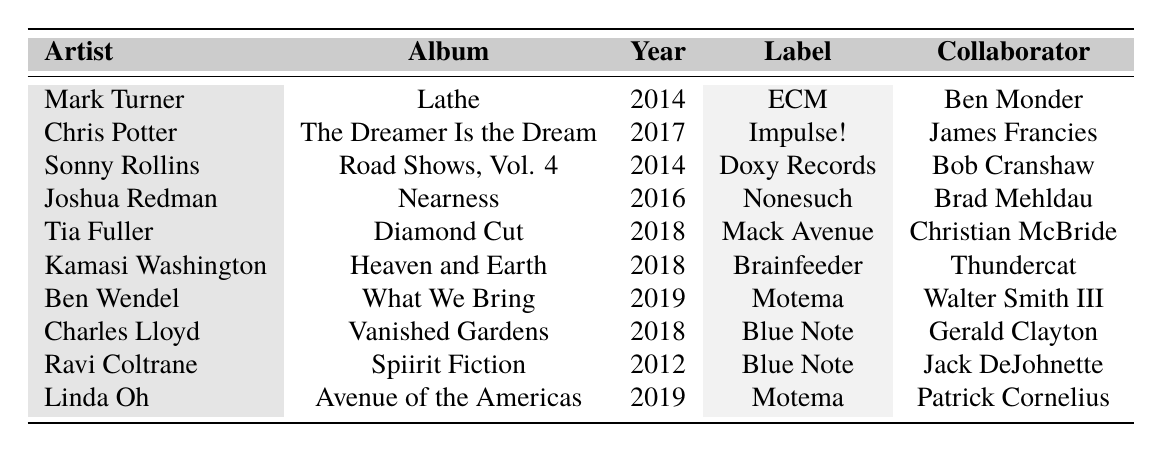What is the title of Mark Turner's album? According to the table, Mark Turner's album is titled "Lathe."
Answer: Lathe How many albums were released by saxophonists in 2018? The table shows three saxophonists released albums in 2018: Tia Fuller, Kamasi Washington, and Charles Lloyd.
Answer: 3 Who collaborated with Chris Potter on his album? The table indicates that Chris Potter collaborated with James Francies on his album, "The Dreamer Is the Dream."
Answer: James Francies Which album was released in 2014? The table lists two albums released in 2014: "Lathe" by Mark Turner and "Road Shows, Vol. 4" by Sonny Rollins.
Answer: Lathe and Road Shows, Vol. 4 What is the total number of albums released by the artists listed? The table contains 10 entries, indicating that there are 10 albums released by the artists listed.
Answer: 10 Is Tia Fuller’s album released on the Impulse! label? The table shows Tia Fuller's album "Diamond Cut" was released on the Mack Avenue label, not Impulse!.
Answer: No Who are the collaborators on Linda Oh's album? According to the table, Linda Oh's album "Avenue of the Americas" has three collaborators: Patrick Cornelius, Jason Palmer, and Willie Jones III.
Answer: Patrick Cornelius, Jason Palmer, Willie Jones III In what year was the most recent album released? The most recent album listed in the table is "What We Bring" by Ben Wendel, released in 2019.
Answer: 2019 How many unique artists are represented in the table? The table shows 9 unique artists: Mark Turner, Chris Potter, Sonny Rollins, Joshua Redman, Tia Fuller, Kamasi Washington, Ben Wendel, Charles Lloyd, Ravi Coltrane, and Linda Oh.
Answer: 9 What is the average release year of the albums in the table? The release years are 2014, 2017, 2014, 2016, 2018, 2018, 2019, 2018, 2012, and 2019. Summing these up gives 2014 + 2017 + 2014 + 2016 + 2018 + 2018 + 2019 + 2018 + 2012 + 2019 = 20161. There are 10 albums, so the average is 20161 / 10 = 2016.1.
Answer: 2016.1 Are there any albums released by saxophonists in the decade starting from 2013 to 2022? All albums listed in the table, except for "Spiirit Fiction" by Ravi Coltrane released in 2012, fall within the decade 2013 to 2022, therefore yes.
Answer: Yes 